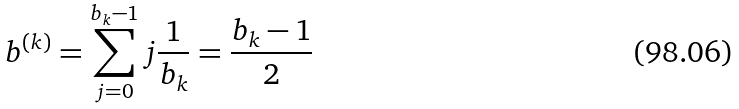Convert formula to latex. <formula><loc_0><loc_0><loc_500><loc_500>b ^ { ( k ) } = \sum _ { j = 0 } ^ { b _ { k } - 1 } j \frac { 1 } { b _ { k } } = \frac { b _ { k } - 1 } { 2 }</formula> 